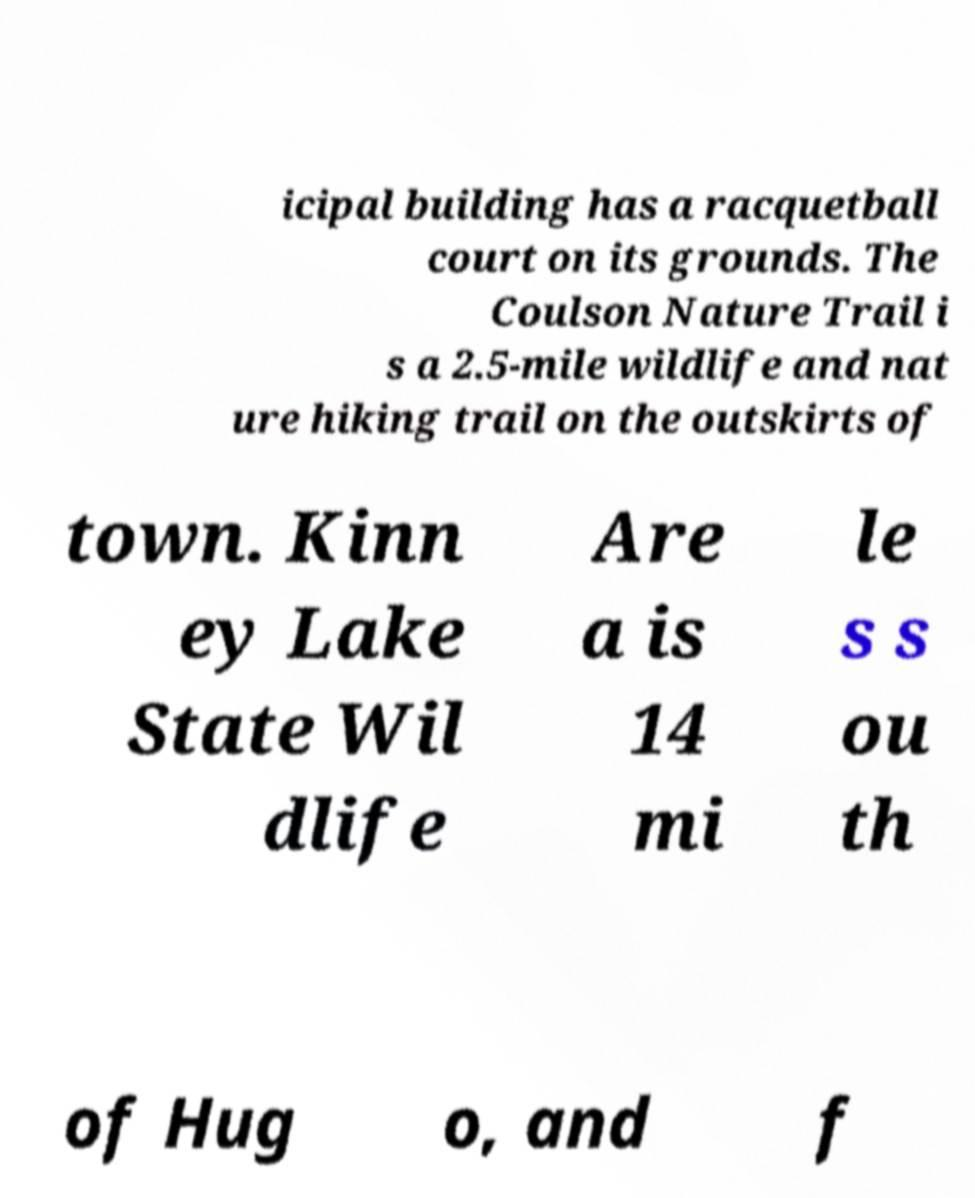Please identify and transcribe the text found in this image. icipal building has a racquetball court on its grounds. The Coulson Nature Trail i s a 2.5-mile wildlife and nat ure hiking trail on the outskirts of town. Kinn ey Lake State Wil dlife Are a is 14 mi le s s ou th of Hug o, and f 